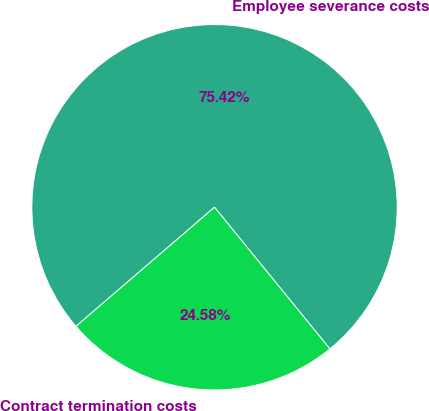Convert chart. <chart><loc_0><loc_0><loc_500><loc_500><pie_chart><fcel>Employee severance costs<fcel>Contract termination costs<nl><fcel>75.42%<fcel>24.58%<nl></chart> 